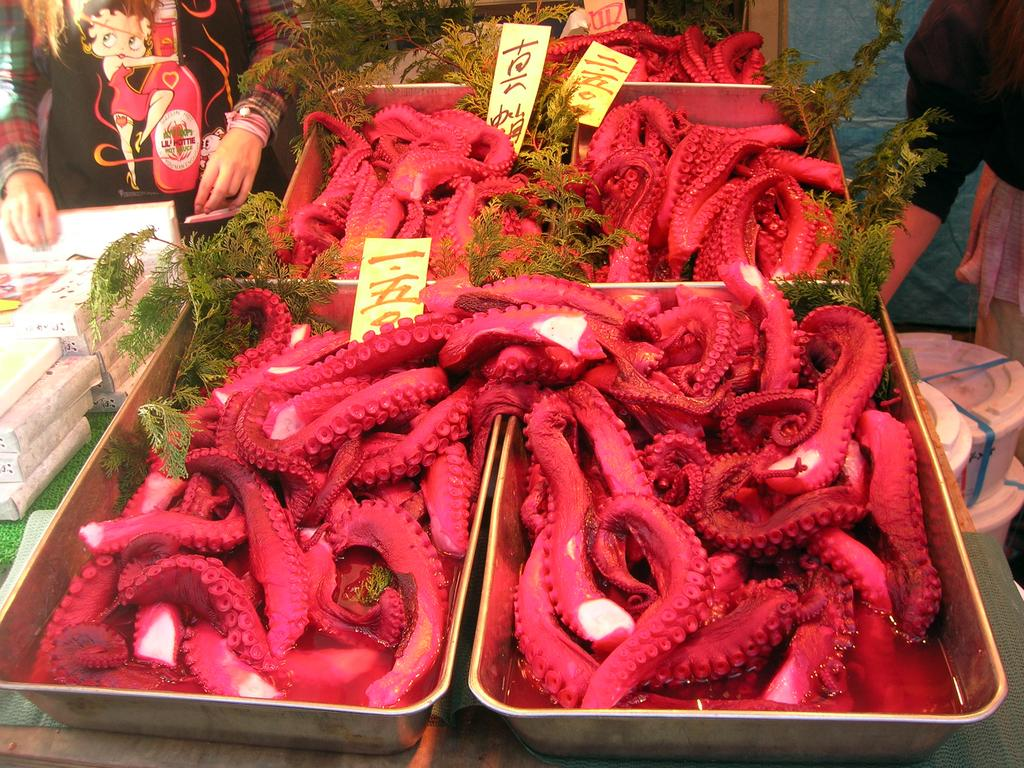What type of sea creature is present in the image? There are octopuses in the image. What can be seen on the left side of the image? There are objects on the left side of the image. Can you describe the background of the image? There are two people in the background of the image. What type of metal is the cork made of in the image? There is no cork present in the image, and therefore no metal can be associated with it. 